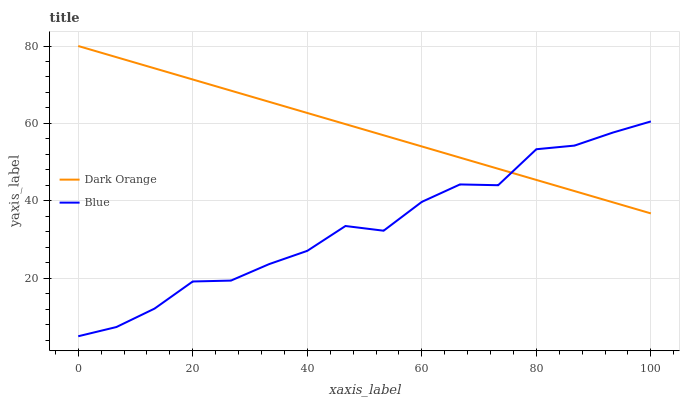Does Blue have the minimum area under the curve?
Answer yes or no. Yes. Does Dark Orange have the maximum area under the curve?
Answer yes or no. Yes. Does Dark Orange have the minimum area under the curve?
Answer yes or no. No. Is Dark Orange the smoothest?
Answer yes or no. Yes. Is Blue the roughest?
Answer yes or no. Yes. Is Dark Orange the roughest?
Answer yes or no. No. Does Blue have the lowest value?
Answer yes or no. Yes. Does Dark Orange have the lowest value?
Answer yes or no. No. Does Dark Orange have the highest value?
Answer yes or no. Yes. Does Dark Orange intersect Blue?
Answer yes or no. Yes. Is Dark Orange less than Blue?
Answer yes or no. No. Is Dark Orange greater than Blue?
Answer yes or no. No. 